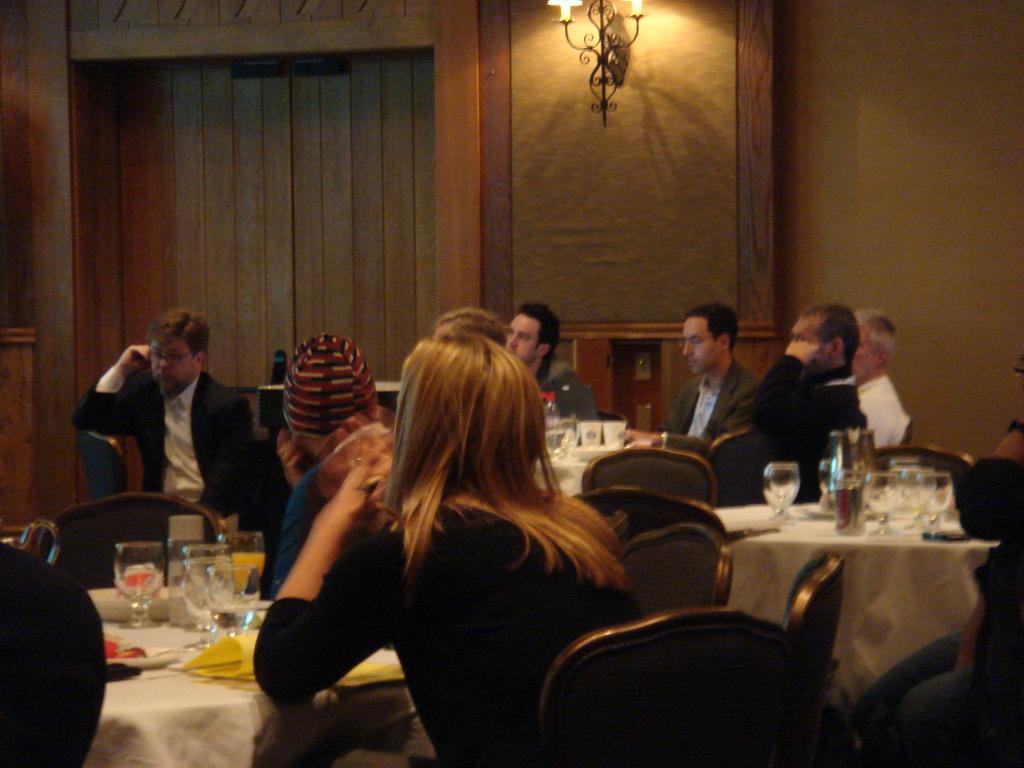Please provide a concise description of this image. A group of people are sitting together around the chairs there are wine glasses on the table. At the top there are lights on the wall. 